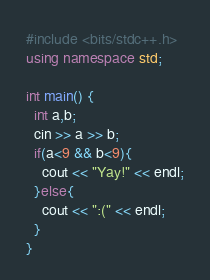<code> <loc_0><loc_0><loc_500><loc_500><_C++_>#include <bits/stdc++.h>
using namespace std;

int main() {
  int a,b;
  cin >> a >> b;
  if(a<9 && b<9){
    cout << "Yay!" << endl;
  }else{
    cout << ":(" << endl;
  }
}

</code> 